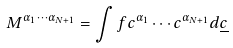Convert formula to latex. <formula><loc_0><loc_0><loc_500><loc_500>M ^ { \alpha _ { 1 } \cdots \alpha _ { N + 1 } } = \int f c ^ { \alpha _ { 1 } } \cdots c ^ { \alpha _ { N + 1 } } d \underline { c }</formula> 